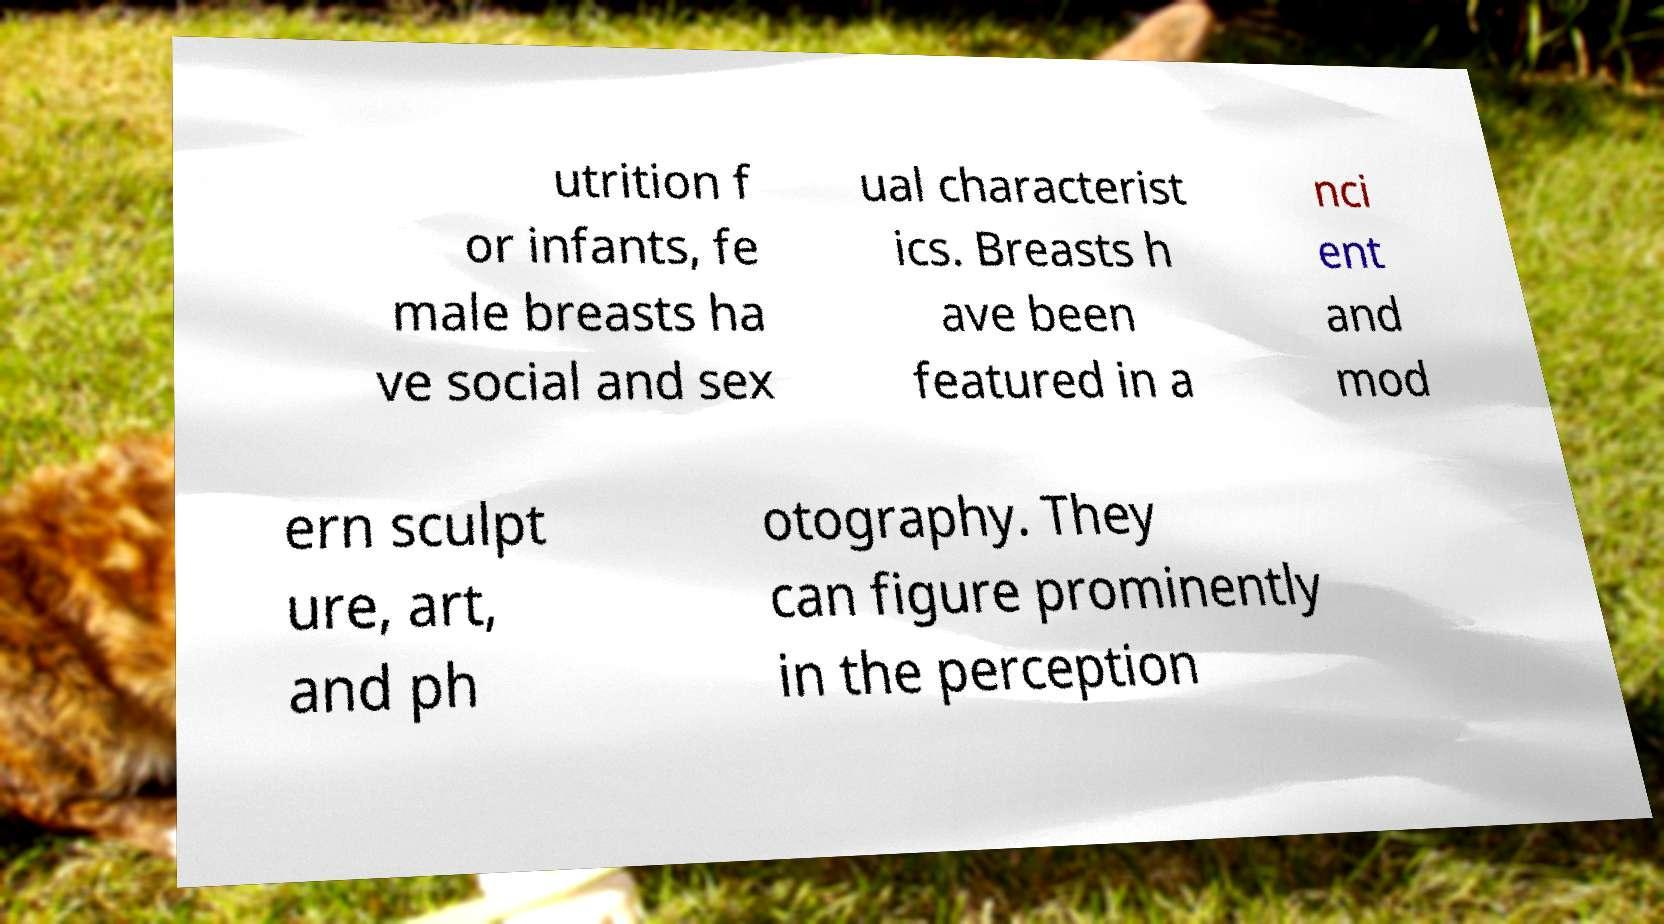For documentation purposes, I need the text within this image transcribed. Could you provide that? utrition f or infants, fe male breasts ha ve social and sex ual characterist ics. Breasts h ave been featured in a nci ent and mod ern sculpt ure, art, and ph otography. They can figure prominently in the perception 